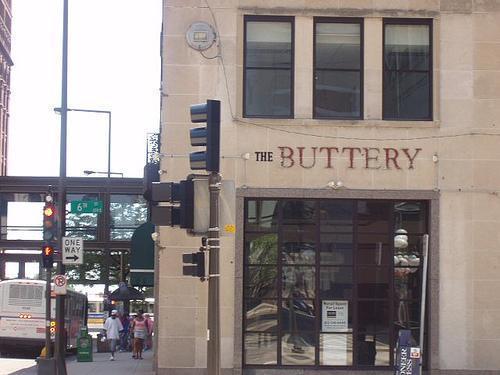How many signs are near the lit up traffic light?
Give a very brief answer. 3. How many buses are visible in this photo?
Give a very brief answer. 1. How many people are in this picture?
Give a very brief answer. 3. How many phones are in the image?
Give a very brief answer. 0. How many buses are in the photo?
Give a very brief answer. 1. How many handles does the refrigerator have?
Give a very brief answer. 0. 